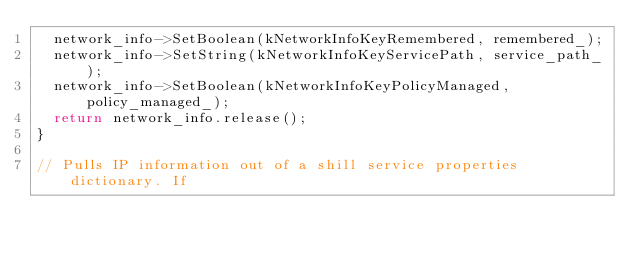<code> <loc_0><loc_0><loc_500><loc_500><_C++_>  network_info->SetBoolean(kNetworkInfoKeyRemembered, remembered_);
  network_info->SetString(kNetworkInfoKeyServicePath, service_path_);
  network_info->SetBoolean(kNetworkInfoKeyPolicyManaged, policy_managed_);
  return network_info.release();
}

// Pulls IP information out of a shill service properties dictionary. If</code> 